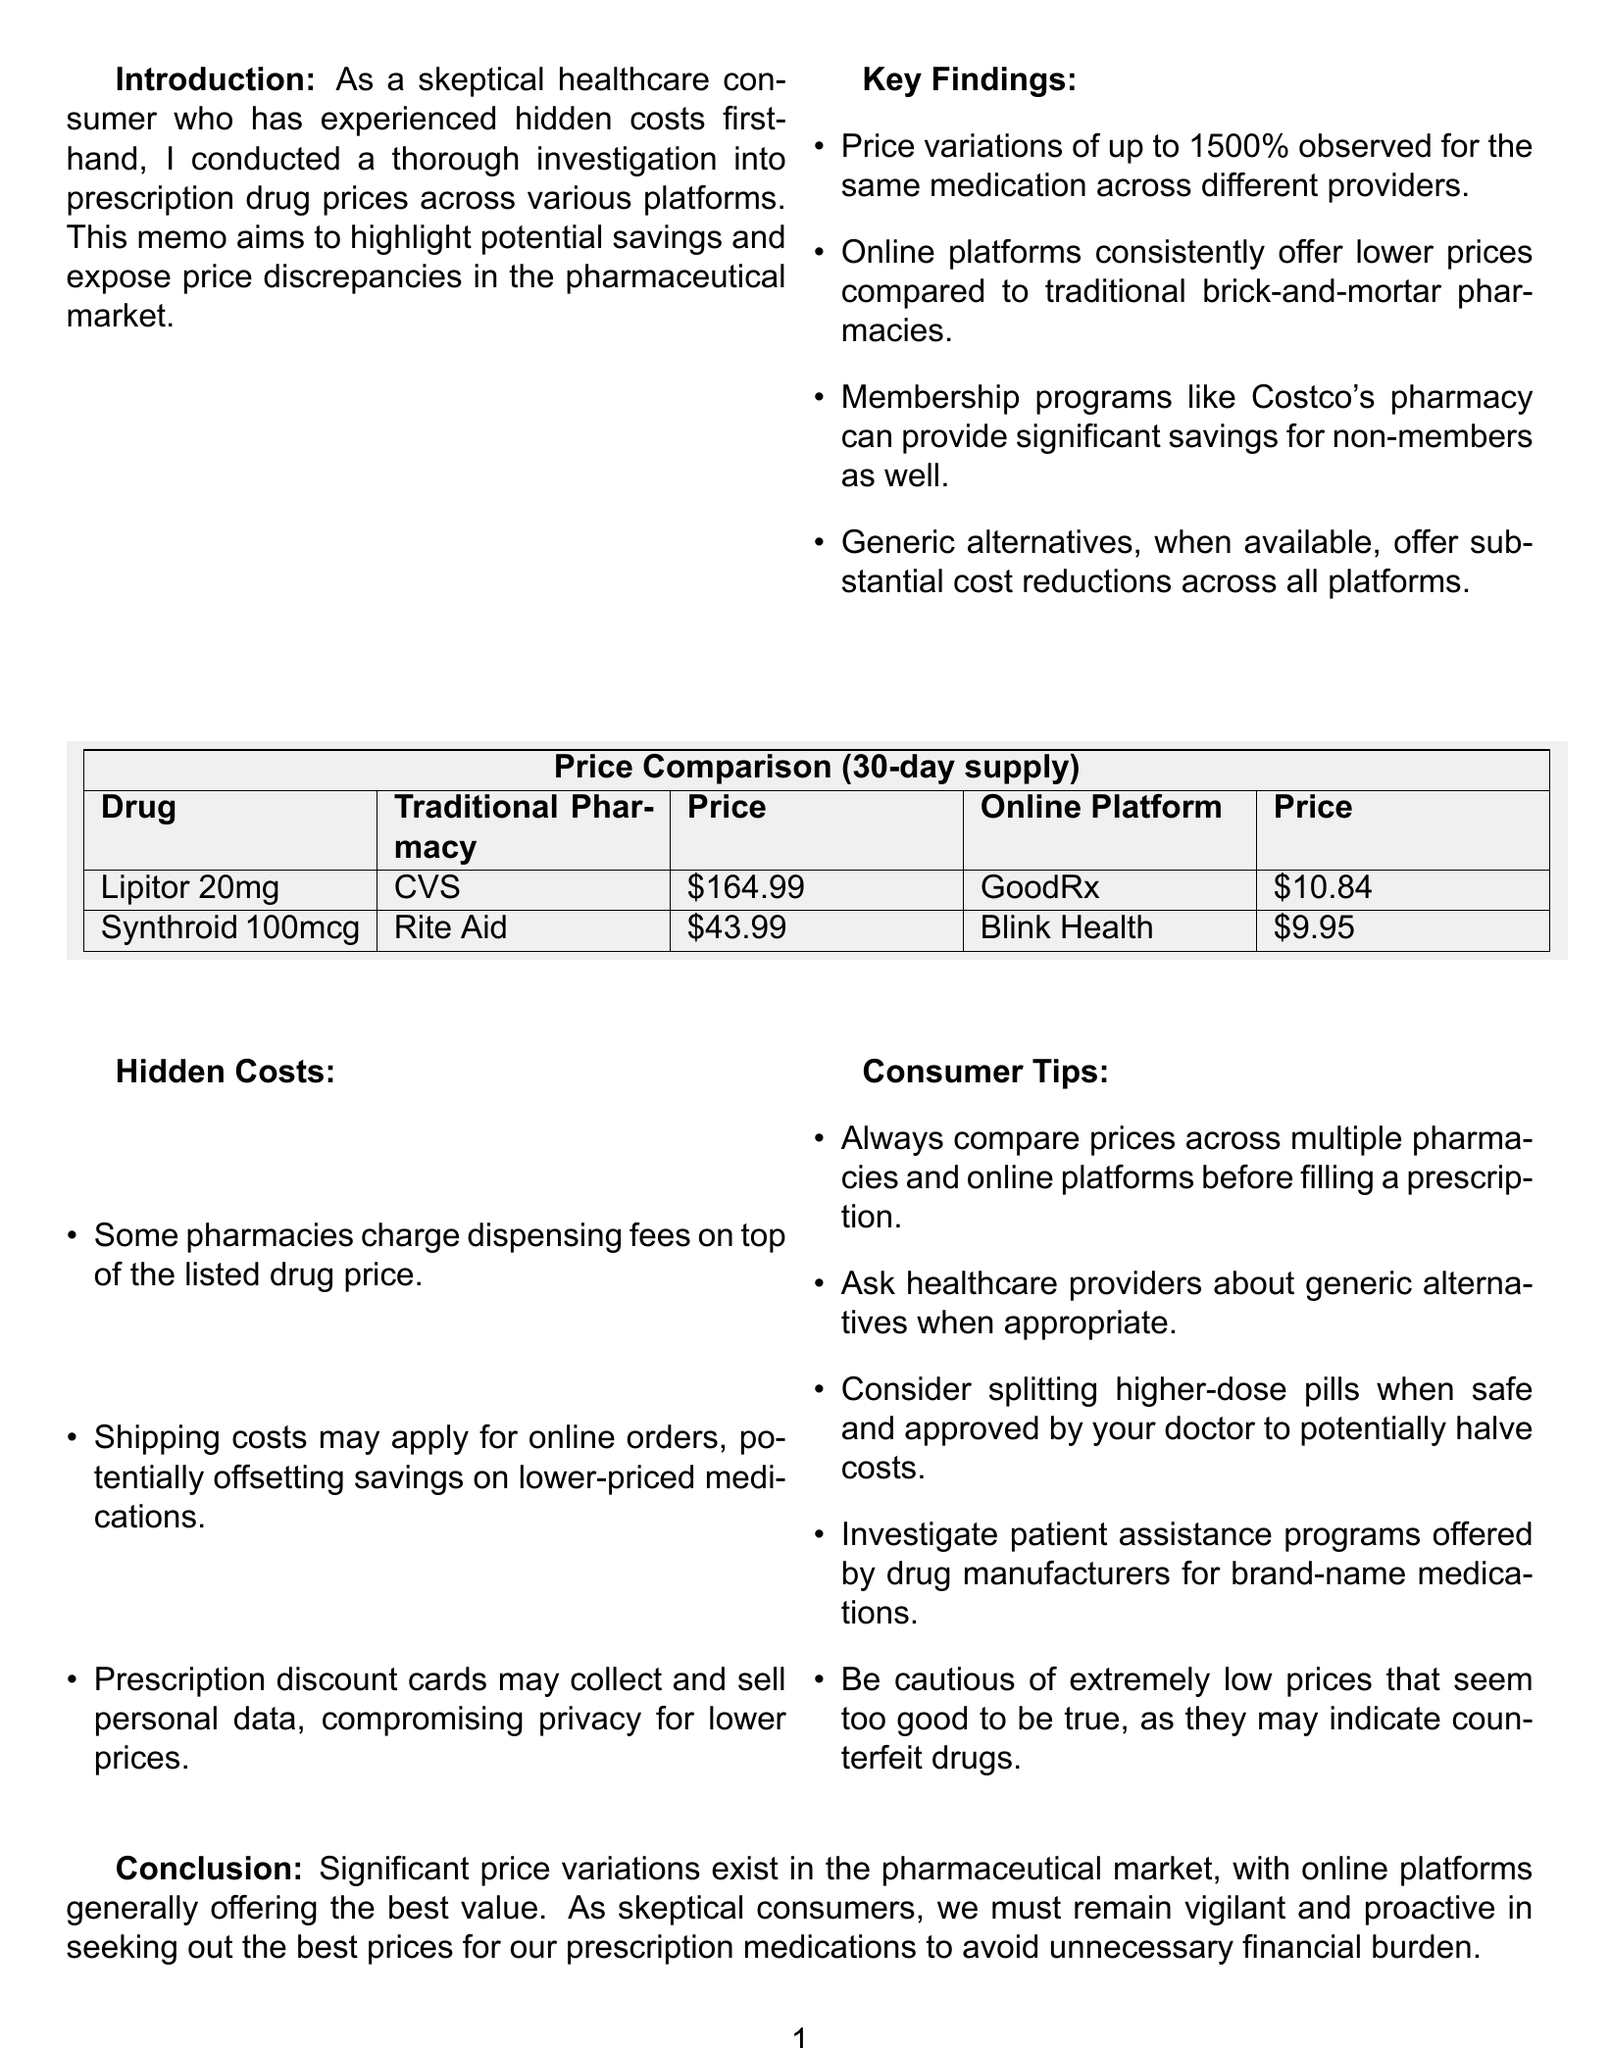What is the price of Lipitor at Walmart? The price of Lipitor at Walmart is listed in the comparison data.
Answer: $68.00 What is the price variation percentage mentioned for medications? The memo states that price variations of up to 1500% were observed for the same medication.
Answer: 1500% Which online platform offers the lowest price for Synthroid? The document lists prices for Synthroid across platforms, indicating that Blink Health has the lowest price.
Answer: Blink Health What is a benefit of membership programs like Costco's pharmacy? The key findings highlight significant savings provided by such membership programs for non-members.
Answer: Significant savings What should consumers be cautious about according to the hidden costs section? The hidden costs section warns consumers about certain issues to consider, particularly regarding low prices.
Answer: Extremely low prices What is one consumer tip mentioned in the document? The consumer tips section suggests a specific strategy for ensuring better medication pricing and value.
Answer: Compare prices across multiple pharmacies How much does GoodRx charge for Lipitor? The price listed for Lipitor on GoodRx in the document's comparison data shows a significant saving compared to traditional pharmacies.
Answer: $10.84 